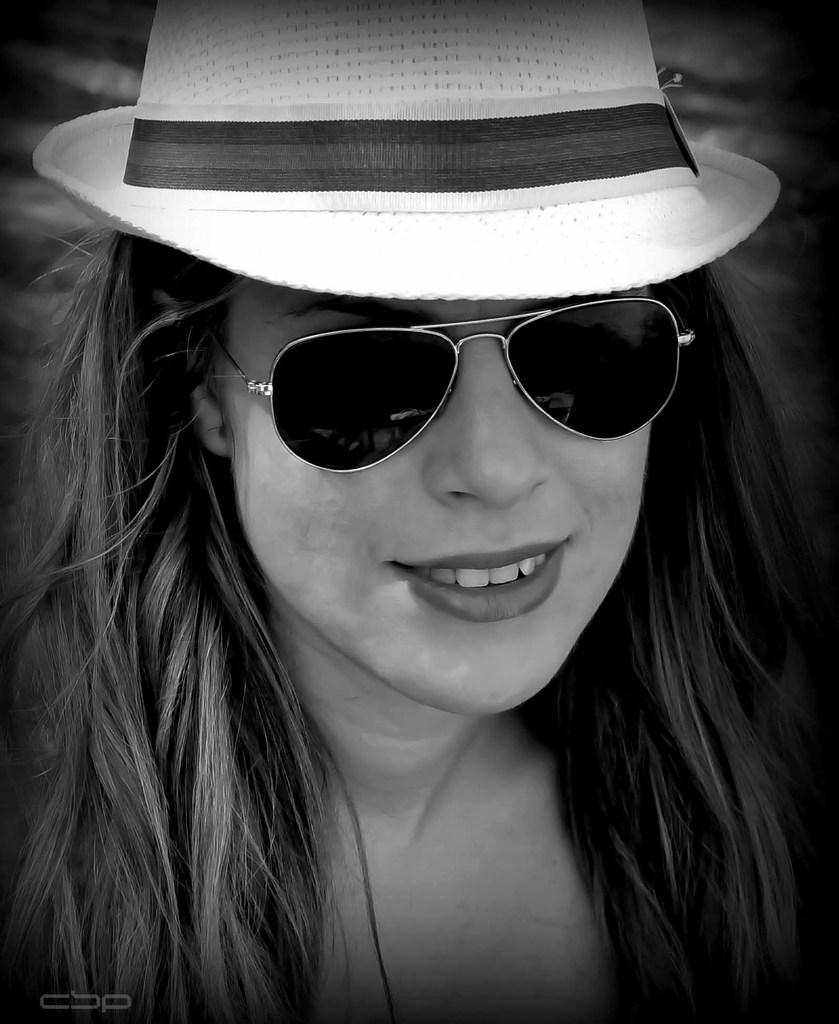Who is present in the image? There is a woman in the picture. What is the woman wearing on her head? The woman is wearing a hat. What type of eyewear is the woman wearing? The woman is wearing shades. Can you describe any additional features of the image? There is a watermark in the left bottom corner of the image, and the image is black and white. What type of force is being applied to the news in the image? There is no news or force present in the image; it features a woman wearing a hat and shades. What type of spade is visible in the image? There is no spade present in the image. 